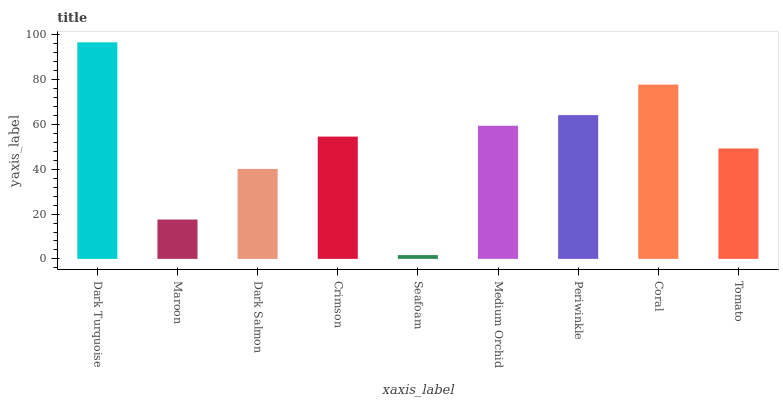Is Seafoam the minimum?
Answer yes or no. Yes. Is Dark Turquoise the maximum?
Answer yes or no. Yes. Is Maroon the minimum?
Answer yes or no. No. Is Maroon the maximum?
Answer yes or no. No. Is Dark Turquoise greater than Maroon?
Answer yes or no. Yes. Is Maroon less than Dark Turquoise?
Answer yes or no. Yes. Is Maroon greater than Dark Turquoise?
Answer yes or no. No. Is Dark Turquoise less than Maroon?
Answer yes or no. No. Is Crimson the high median?
Answer yes or no. Yes. Is Crimson the low median?
Answer yes or no. Yes. Is Tomato the high median?
Answer yes or no. No. Is Seafoam the low median?
Answer yes or no. No. 